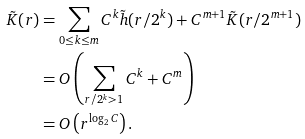<formula> <loc_0><loc_0><loc_500><loc_500>\tilde { K } ( r ) & = \sum _ { 0 \leq k \leq m } C ^ { k } \tilde { h } ( r / 2 ^ { k } ) + C ^ { m + 1 } \tilde { K } ( r / 2 ^ { m + 1 } ) \\ & = O \left ( \sum _ { r / 2 ^ { k } > 1 } C ^ { k } + C ^ { m } \right ) \\ & = O \left ( r ^ { \log _ { 2 } C } \right ) .</formula> 